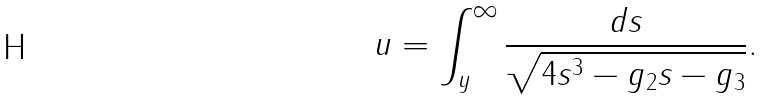<formula> <loc_0><loc_0><loc_500><loc_500>u = \int _ { y } ^ { \infty } { \frac { d s } { \sqrt { 4 s ^ { 3 } - g _ { 2 } s - g _ { 3 } } } } .</formula> 